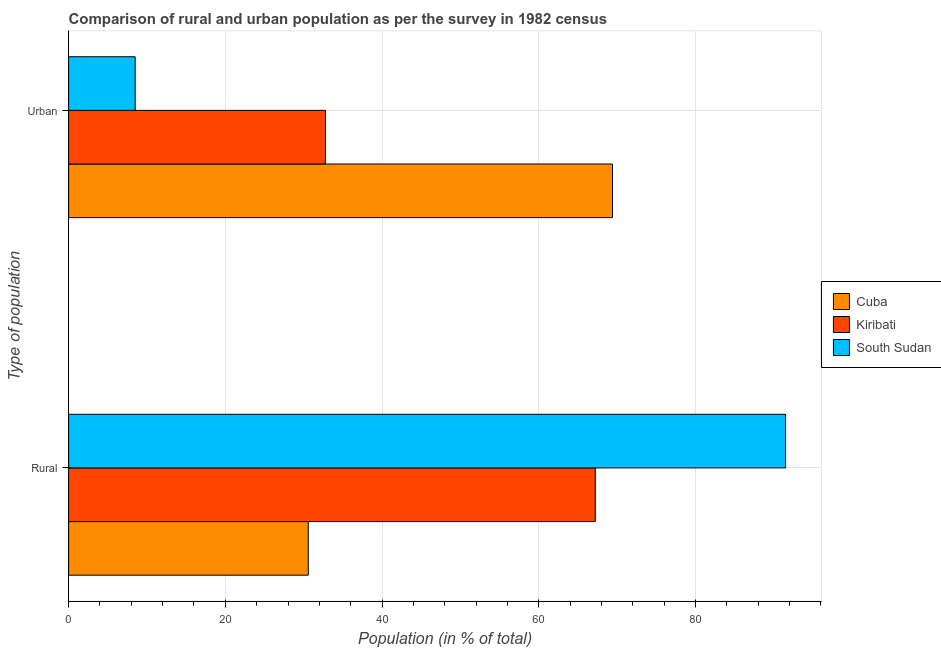How many different coloured bars are there?
Offer a very short reply. 3. How many groups of bars are there?
Keep it short and to the point. 2. How many bars are there on the 2nd tick from the top?
Your answer should be compact. 3. How many bars are there on the 1st tick from the bottom?
Make the answer very short. 3. What is the label of the 1st group of bars from the top?
Your answer should be compact. Urban. What is the urban population in South Sudan?
Provide a succinct answer. 8.5. Across all countries, what is the maximum rural population?
Keep it short and to the point. 91.5. Across all countries, what is the minimum rural population?
Keep it short and to the point. 30.59. In which country was the rural population maximum?
Offer a very short reply. South Sudan. In which country was the rural population minimum?
Give a very brief answer. Cuba. What is the total rural population in the graph?
Keep it short and to the point. 189.31. What is the difference between the urban population in Kiribati and that in Cuba?
Give a very brief answer. -36.63. What is the difference between the rural population in Cuba and the urban population in Kiribati?
Make the answer very short. -2.2. What is the average urban population per country?
Make the answer very short. 36.9. What is the difference between the rural population and urban population in Cuba?
Provide a succinct answer. -38.83. In how many countries, is the rural population greater than 76 %?
Ensure brevity in your answer.  1. What is the ratio of the rural population in South Sudan to that in Cuba?
Make the answer very short. 2.99. In how many countries, is the rural population greater than the average rural population taken over all countries?
Keep it short and to the point. 2. What does the 1st bar from the top in Urban represents?
Give a very brief answer. South Sudan. What does the 1st bar from the bottom in Urban represents?
Give a very brief answer. Cuba. How many bars are there?
Make the answer very short. 6. Are all the bars in the graph horizontal?
Provide a succinct answer. Yes. How many countries are there in the graph?
Make the answer very short. 3. What is the difference between two consecutive major ticks on the X-axis?
Offer a terse response. 20. Does the graph contain any zero values?
Give a very brief answer. No. Does the graph contain grids?
Your response must be concise. Yes. Where does the legend appear in the graph?
Give a very brief answer. Center right. How many legend labels are there?
Make the answer very short. 3. How are the legend labels stacked?
Give a very brief answer. Vertical. What is the title of the graph?
Offer a terse response. Comparison of rural and urban population as per the survey in 1982 census. Does "Spain" appear as one of the legend labels in the graph?
Offer a very short reply. No. What is the label or title of the X-axis?
Offer a terse response. Population (in % of total). What is the label or title of the Y-axis?
Provide a succinct answer. Type of population. What is the Population (in % of total) in Cuba in Rural?
Keep it short and to the point. 30.59. What is the Population (in % of total) in Kiribati in Rural?
Your answer should be compact. 67.22. What is the Population (in % of total) of South Sudan in Rural?
Offer a very short reply. 91.5. What is the Population (in % of total) of Cuba in Urban?
Your answer should be very brief. 69.41. What is the Population (in % of total) in Kiribati in Urban?
Your response must be concise. 32.78. What is the Population (in % of total) in South Sudan in Urban?
Offer a very short reply. 8.5. Across all Type of population, what is the maximum Population (in % of total) in Cuba?
Your answer should be very brief. 69.41. Across all Type of population, what is the maximum Population (in % of total) of Kiribati?
Offer a terse response. 67.22. Across all Type of population, what is the maximum Population (in % of total) in South Sudan?
Make the answer very short. 91.5. Across all Type of population, what is the minimum Population (in % of total) of Cuba?
Make the answer very short. 30.59. Across all Type of population, what is the minimum Population (in % of total) of Kiribati?
Keep it short and to the point. 32.78. Across all Type of population, what is the minimum Population (in % of total) of South Sudan?
Your response must be concise. 8.5. What is the total Population (in % of total) of Cuba in the graph?
Offer a very short reply. 100. What is the total Population (in % of total) in South Sudan in the graph?
Offer a terse response. 100. What is the difference between the Population (in % of total) of Cuba in Rural and that in Urban?
Provide a short and direct response. -38.83. What is the difference between the Population (in % of total) of Kiribati in Rural and that in Urban?
Make the answer very short. 34.44. What is the difference between the Population (in % of total) in South Sudan in Rural and that in Urban?
Keep it short and to the point. 83.01. What is the difference between the Population (in % of total) in Cuba in Rural and the Population (in % of total) in Kiribati in Urban?
Ensure brevity in your answer.  -2.2. What is the difference between the Population (in % of total) in Cuba in Rural and the Population (in % of total) in South Sudan in Urban?
Offer a very short reply. 22.09. What is the difference between the Population (in % of total) of Kiribati in Rural and the Population (in % of total) of South Sudan in Urban?
Ensure brevity in your answer.  58.72. What is the average Population (in % of total) in Kiribati per Type of population?
Give a very brief answer. 50. What is the average Population (in % of total) of South Sudan per Type of population?
Keep it short and to the point. 50. What is the difference between the Population (in % of total) of Cuba and Population (in % of total) of Kiribati in Rural?
Your answer should be very brief. -36.63. What is the difference between the Population (in % of total) of Cuba and Population (in % of total) of South Sudan in Rural?
Keep it short and to the point. -60.92. What is the difference between the Population (in % of total) of Kiribati and Population (in % of total) of South Sudan in Rural?
Offer a terse response. -24.29. What is the difference between the Population (in % of total) of Cuba and Population (in % of total) of Kiribati in Urban?
Give a very brief answer. 36.63. What is the difference between the Population (in % of total) in Cuba and Population (in % of total) in South Sudan in Urban?
Ensure brevity in your answer.  60.92. What is the difference between the Population (in % of total) of Kiribati and Population (in % of total) of South Sudan in Urban?
Your answer should be very brief. 24.29. What is the ratio of the Population (in % of total) of Cuba in Rural to that in Urban?
Your answer should be very brief. 0.44. What is the ratio of the Population (in % of total) in Kiribati in Rural to that in Urban?
Offer a terse response. 2.05. What is the ratio of the Population (in % of total) of South Sudan in Rural to that in Urban?
Your answer should be compact. 10.77. What is the difference between the highest and the second highest Population (in % of total) in Cuba?
Keep it short and to the point. 38.83. What is the difference between the highest and the second highest Population (in % of total) of Kiribati?
Ensure brevity in your answer.  34.44. What is the difference between the highest and the second highest Population (in % of total) of South Sudan?
Your response must be concise. 83.01. What is the difference between the highest and the lowest Population (in % of total) in Cuba?
Offer a very short reply. 38.83. What is the difference between the highest and the lowest Population (in % of total) of Kiribati?
Provide a short and direct response. 34.44. What is the difference between the highest and the lowest Population (in % of total) in South Sudan?
Keep it short and to the point. 83.01. 